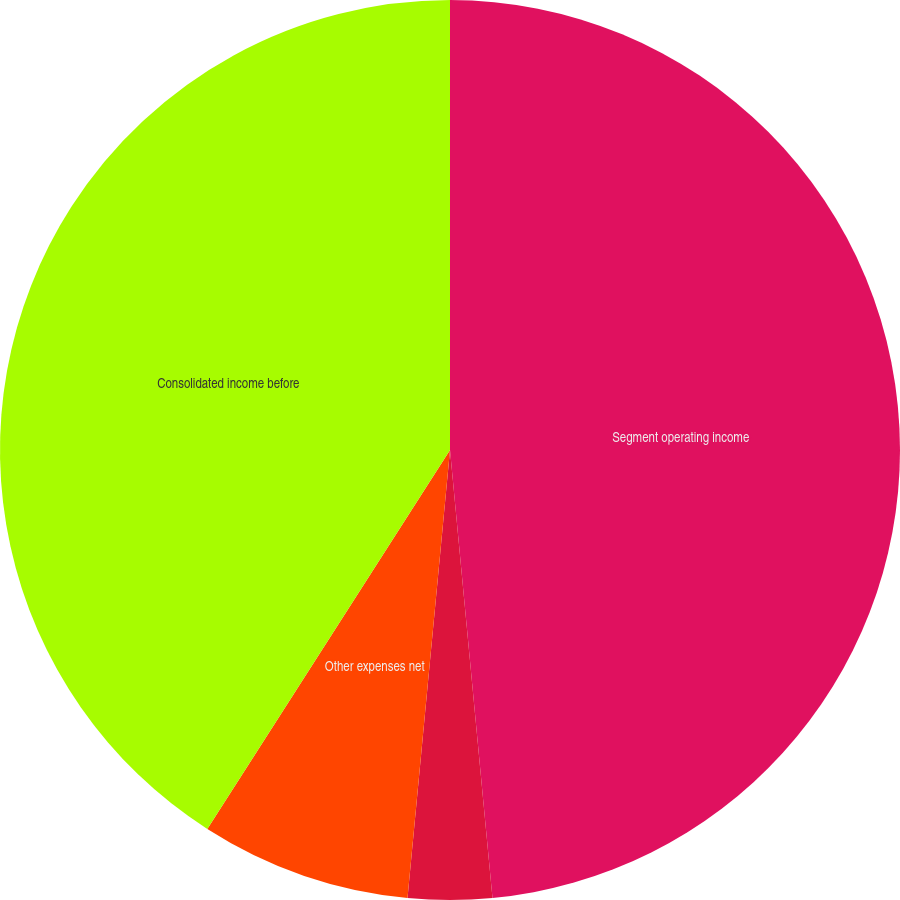Convert chart. <chart><loc_0><loc_0><loc_500><loc_500><pie_chart><fcel>Segment operating income<fcel>Interest expense<fcel>Other expenses net<fcel>Consolidated income before<nl><fcel>48.49%<fcel>3.01%<fcel>7.56%<fcel>40.93%<nl></chart> 